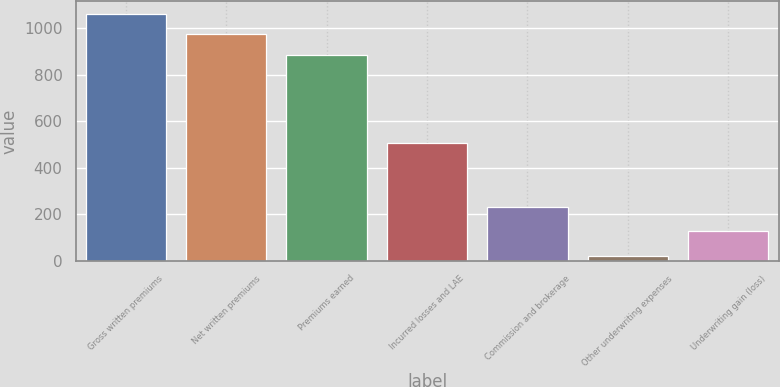Convert chart to OTSL. <chart><loc_0><loc_0><loc_500><loc_500><bar_chart><fcel>Gross written premiums<fcel>Net written premiums<fcel>Premiums earned<fcel>Incurred losses and LAE<fcel>Commission and brokerage<fcel>Other underwriting expenses<fcel>Underwriting gain (loss)<nl><fcel>1062.48<fcel>973.99<fcel>885.5<fcel>504.8<fcel>230.9<fcel>19.8<fcel>129.9<nl></chart> 